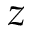<formula> <loc_0><loc_0><loc_500><loc_500>z</formula> 